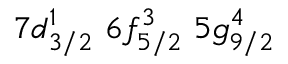<formula> <loc_0><loc_0><loc_500><loc_500>7 d _ { 3 / 2 } ^ { 1 } \, 6 f _ { 5 / 2 } ^ { 3 } \, 5 g _ { 9 / 2 } ^ { 4 }</formula> 